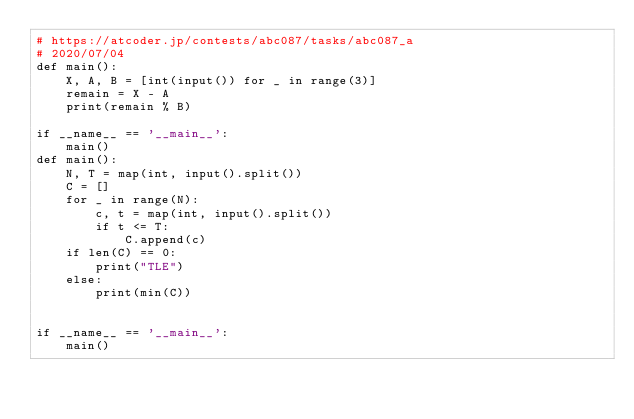Convert code to text. <code><loc_0><loc_0><loc_500><loc_500><_Python_># https://atcoder.jp/contests/abc087/tasks/abc087_a
# 2020/07/04
def main():
    X, A, B = [int(input()) for _ in range(3)]
    remain = X - A
    print(remain % B)

if __name__ == '__main__':
    main()
def main():
    N, T = map(int, input().split())
    C = []
    for _ in range(N):
        c, t = map(int, input().split())
        if t <= T:
            C.append(c)
    if len(C) == 0:
        print("TLE")
    else:
        print(min(C))


if __name__ == '__main__':
    main()
</code> 